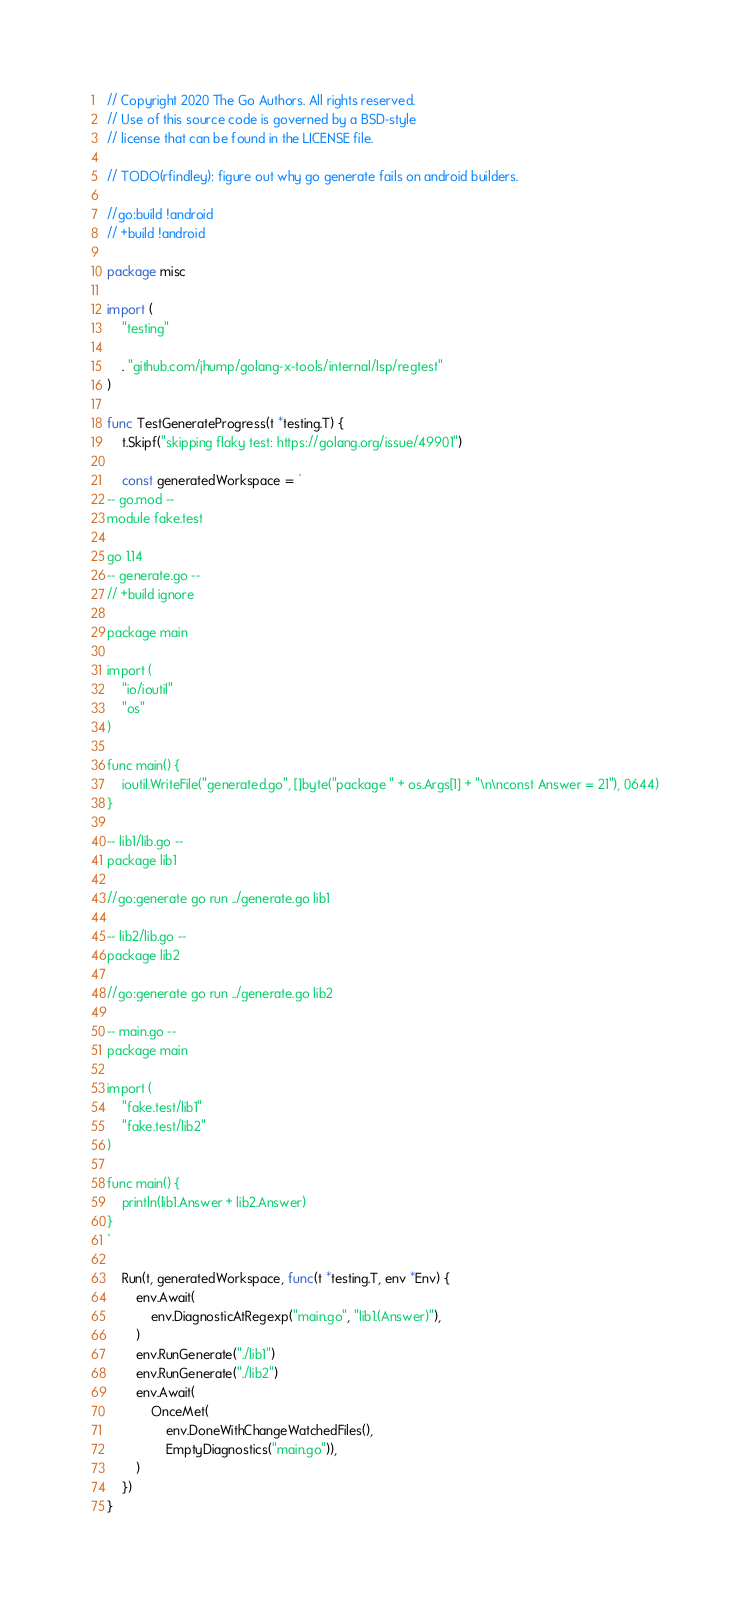<code> <loc_0><loc_0><loc_500><loc_500><_Go_>// Copyright 2020 The Go Authors. All rights reserved.
// Use of this source code is governed by a BSD-style
// license that can be found in the LICENSE file.

// TODO(rfindley): figure out why go generate fails on android builders.

//go:build !android
// +build !android

package misc

import (
	"testing"

	. "github.com/jhump/golang-x-tools/internal/lsp/regtest"
)

func TestGenerateProgress(t *testing.T) {
	t.Skipf("skipping flaky test: https://golang.org/issue/49901")

	const generatedWorkspace = `
-- go.mod --
module fake.test

go 1.14
-- generate.go --
// +build ignore

package main

import (
	"io/ioutil"
	"os"
)

func main() {
	ioutil.WriteFile("generated.go", []byte("package " + os.Args[1] + "\n\nconst Answer = 21"), 0644)
}

-- lib1/lib.go --
package lib1

//go:generate go run ../generate.go lib1

-- lib2/lib.go --
package lib2

//go:generate go run ../generate.go lib2

-- main.go --
package main

import (
	"fake.test/lib1"
	"fake.test/lib2"
)

func main() {
	println(lib1.Answer + lib2.Answer)
}
`

	Run(t, generatedWorkspace, func(t *testing.T, env *Env) {
		env.Await(
			env.DiagnosticAtRegexp("main.go", "lib1.(Answer)"),
		)
		env.RunGenerate("./lib1")
		env.RunGenerate("./lib2")
		env.Await(
			OnceMet(
				env.DoneWithChangeWatchedFiles(),
				EmptyDiagnostics("main.go")),
		)
	})
}
</code> 